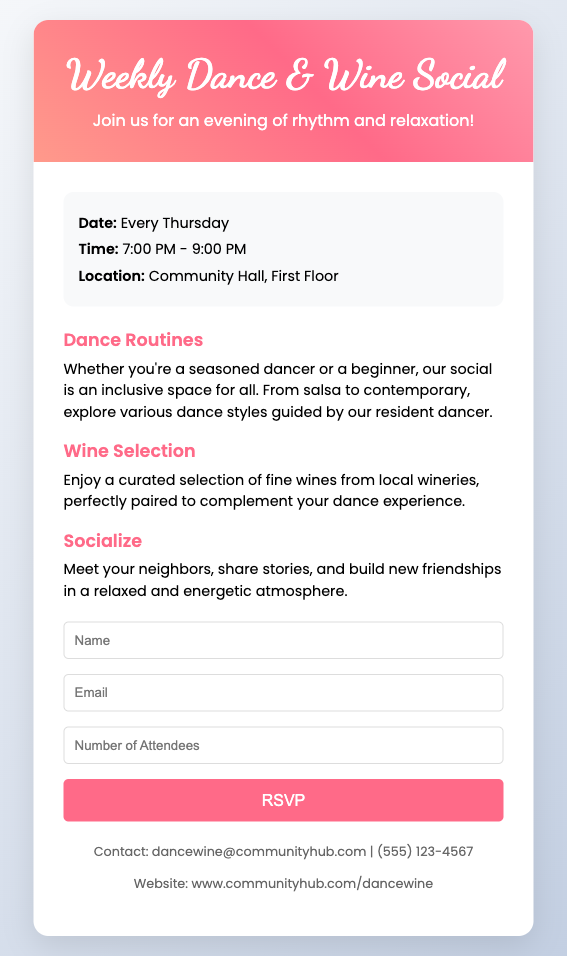What day of the week is the social held? The document states that the social is held every Thursday.
Answer: Every Thursday What time does the event start? The event details mention that the start time is 7:00 PM.
Answer: 7:00 PM Where will the dance social take place? According to the event details, the location is the Community Hall, First Floor.
Answer: Community Hall, First Floor What types of dance are mentioned? The document includes a mention of various dance styles, such as salsa and contemporary.
Answer: Salsa, contemporary How can attendees RSVP? The RSVP process is through a form that requires name, email, and the number of attendees.
Answer: Through a form What is the primary focus of the highlights section? The highlights section emphasizes dance routines, wine selection, and socializing opportunities.
Answer: Dance routines, wine selection, socializing What is the contact email provided for questions? The document provides a specific email for inquiries which is dancewine@communityhub.com.
Answer: dancewine@communityhub.com How long does the event last? The event is scheduled for a duration mentioned in the time, which is from 7:00 PM to 9:00 PM, totaling 2 hours.
Answer: 2 hours What kind of atmosphere is described for the gathering? The document depicts the atmosphere as relaxed and energetic.
Answer: Relaxed, energetic 